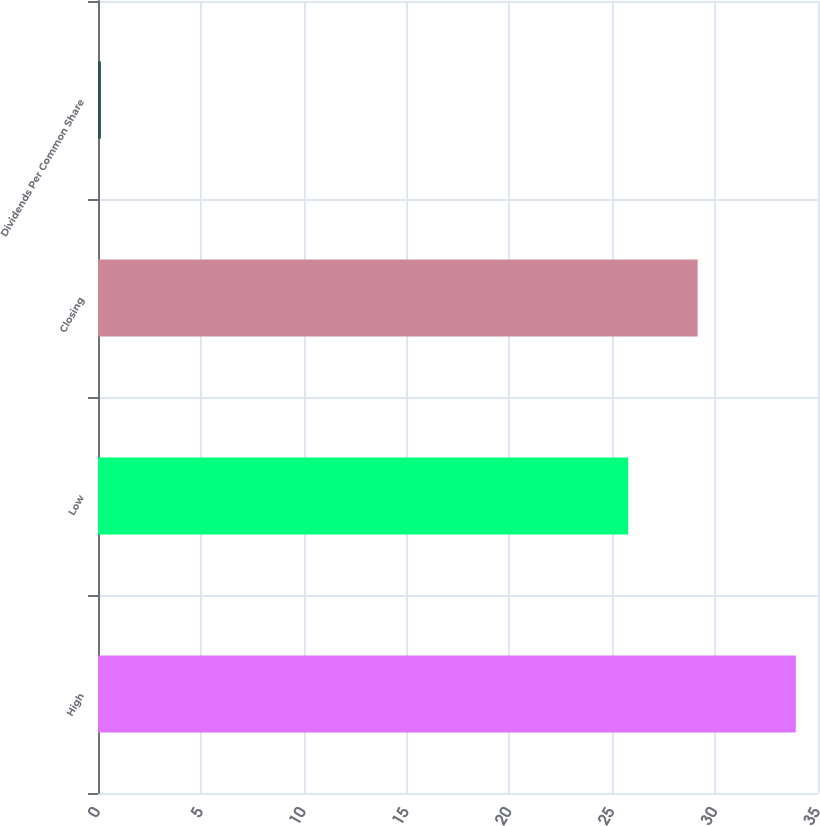<chart> <loc_0><loc_0><loc_500><loc_500><bar_chart><fcel>High<fcel>Low<fcel>Closing<fcel>Dividends Per Common Share<nl><fcel>33.92<fcel>25.77<fcel>29.15<fcel>0.14<nl></chart> 